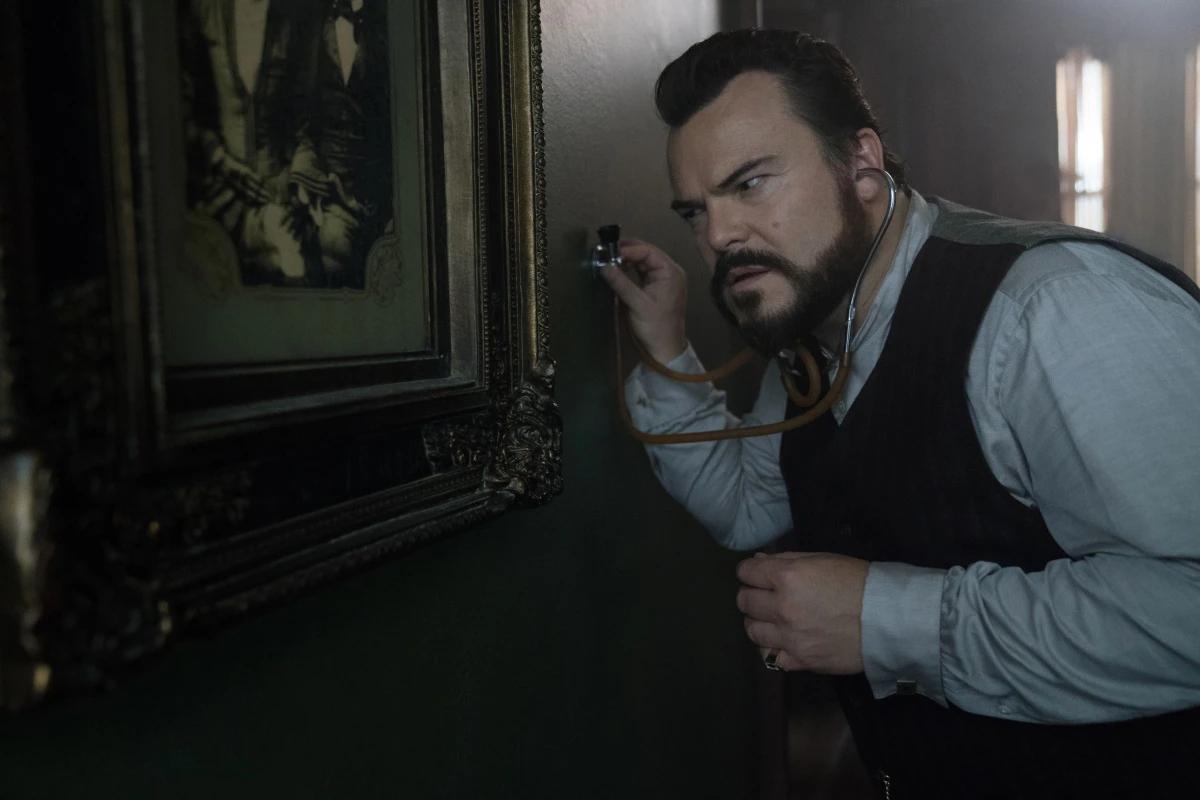Can you describe the character's emotional state? The character appears to be deeply focused, with a serious and slightly concerned expression on his face. The way he presses the stethoscope against the wall and listens intently suggests that he is in the middle of a critical investigation or trying to gather important information. His furrowed brows and intense look also indicate that he might be under pressure or sensing something suspicious. Why might he be using a stethoscope on a wall with an old painting? He could be using the stethoscope to listen for sounds coming from the other side of the wall. This technique is often used in investigative scenarios where the character might suspect hidden activities, such as secret conversations or movements, happening behind the wall. The stethoscope can amplify faint sounds, allowing him to detect subtle noises that wouldn't be audible otherwise. The presence of the old painting might add historical or sentimental value to the scene, further deepening the mystery. 